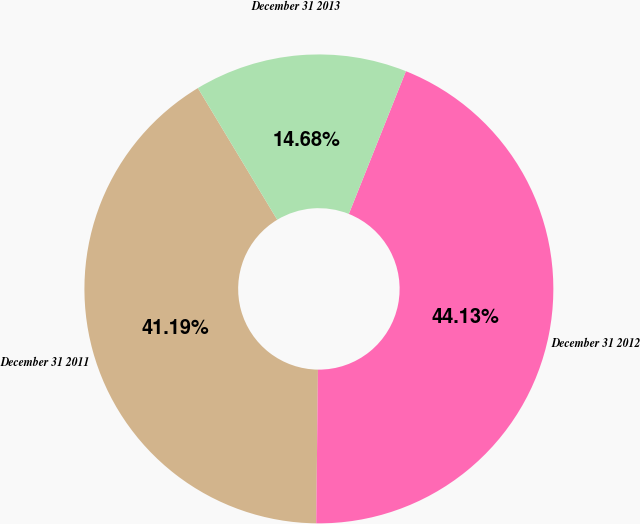Convert chart. <chart><loc_0><loc_0><loc_500><loc_500><pie_chart><fcel>December 31 2011<fcel>December 31 2012<fcel>December 31 2013<nl><fcel>41.19%<fcel>44.13%<fcel>14.68%<nl></chart> 